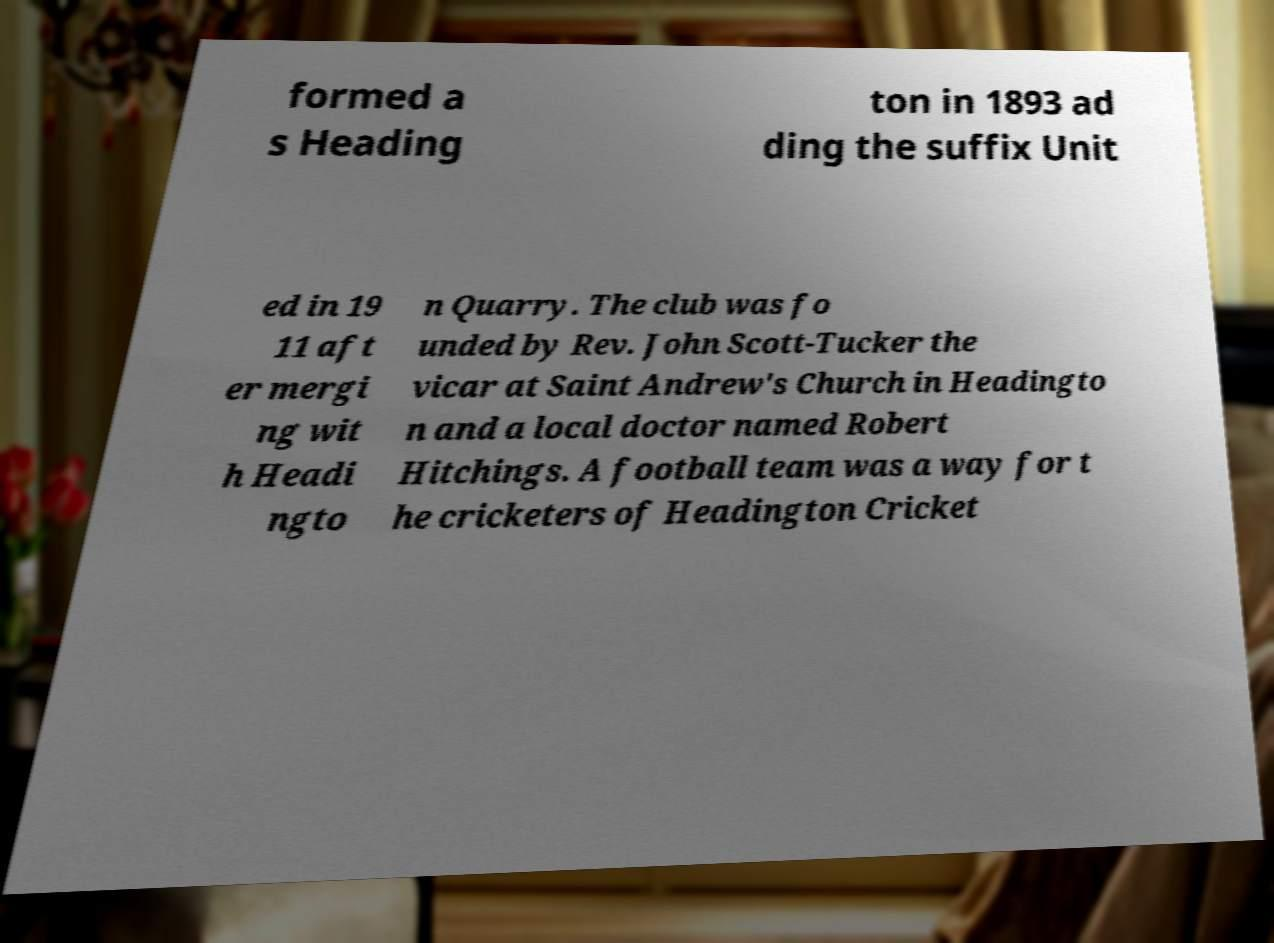Please read and relay the text visible in this image. What does it say? formed a s Heading ton in 1893 ad ding the suffix Unit ed in 19 11 aft er mergi ng wit h Headi ngto n Quarry. The club was fo unded by Rev. John Scott-Tucker the vicar at Saint Andrew's Church in Headingto n and a local doctor named Robert Hitchings. A football team was a way for t he cricketers of Headington Cricket 